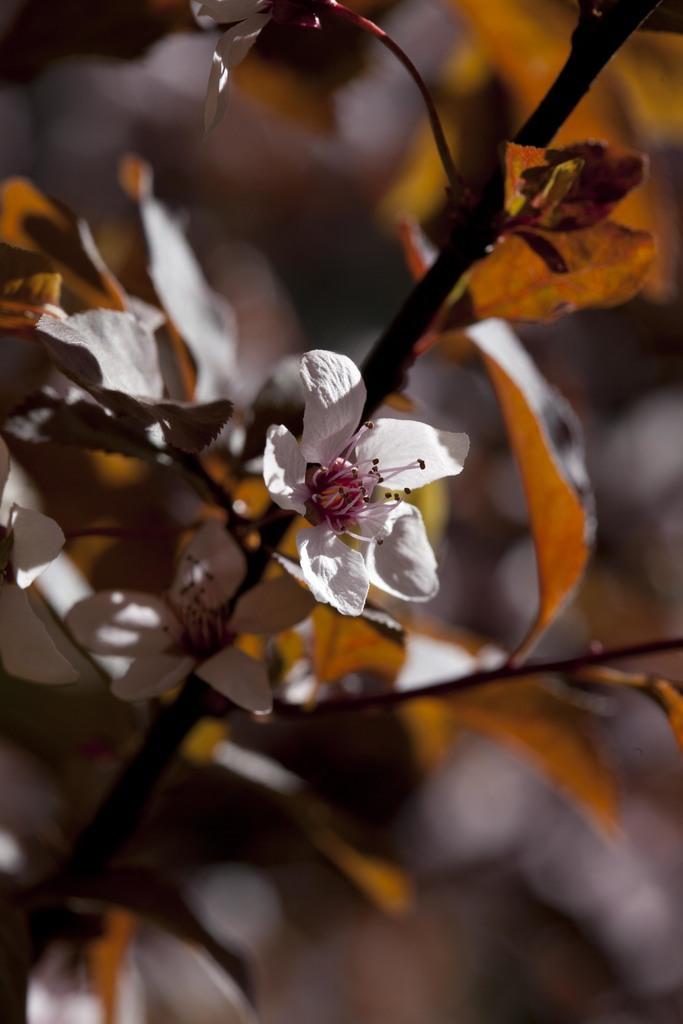Can you describe this image briefly? In this picture I can see there is a white flower and there is a stem and few leaves, the backdrop is blurred. 